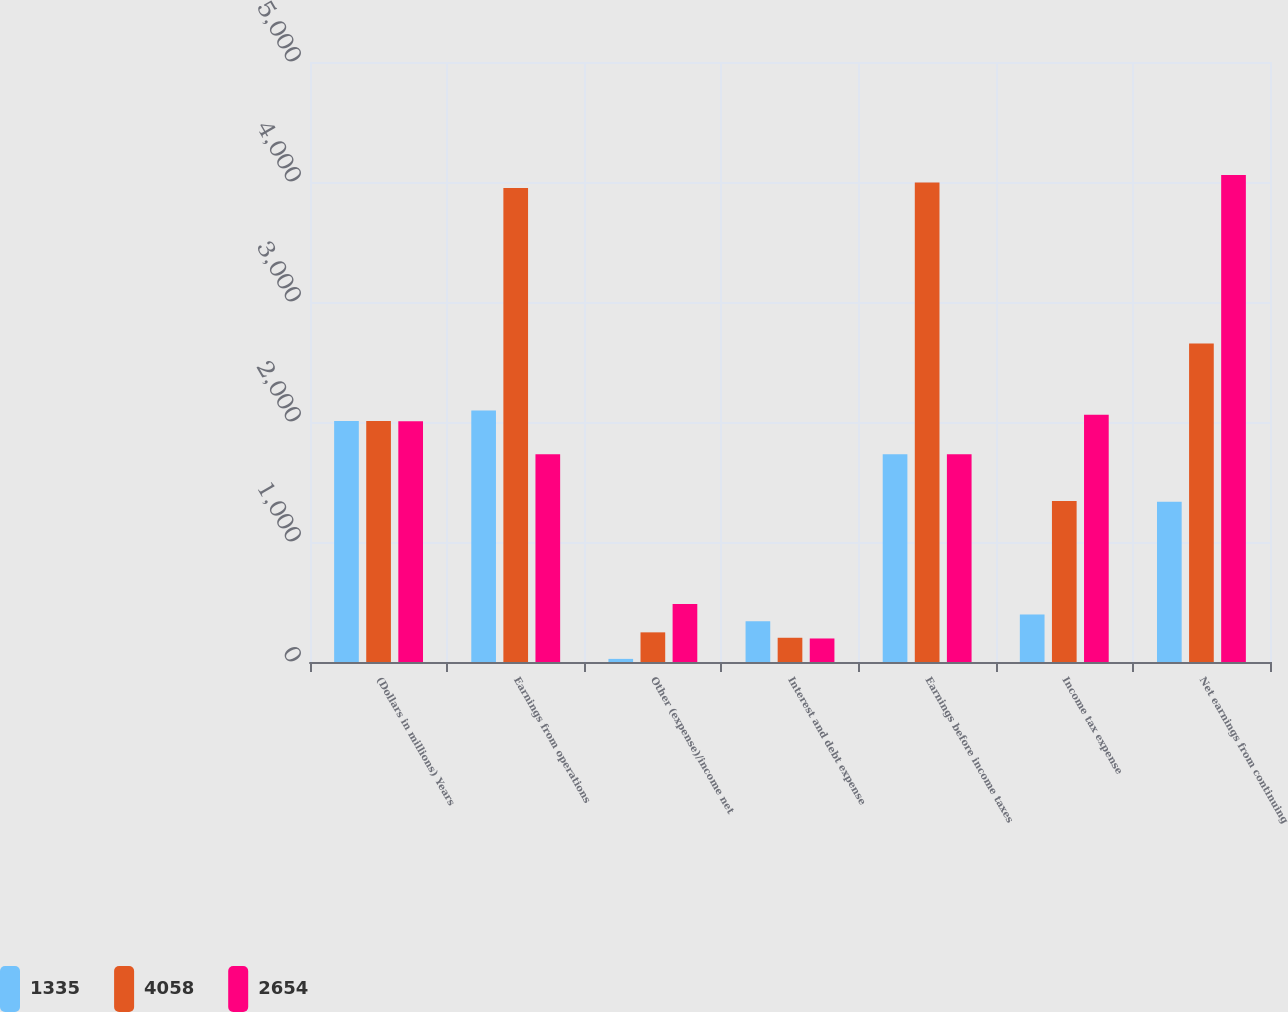Convert chart to OTSL. <chart><loc_0><loc_0><loc_500><loc_500><stacked_bar_chart><ecel><fcel>(Dollars in millions) Years<fcel>Earnings from operations<fcel>Other (expense)/income net<fcel>Interest and debt expense<fcel>Earnings before income taxes<fcel>Income tax expense<fcel>Net earnings from continuing<nl><fcel>1335<fcel>2009<fcel>2096<fcel>26<fcel>339<fcel>1731<fcel>396<fcel>1335<nl><fcel>4058<fcel>2008<fcel>3950<fcel>247<fcel>202<fcel>3995<fcel>1341<fcel>2654<nl><fcel>2654<fcel>2007<fcel>1731<fcel>484<fcel>196<fcel>1731<fcel>2060<fcel>4058<nl></chart> 